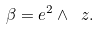<formula> <loc_0><loc_0><loc_500><loc_500>\beta = e ^ { 2 } \wedge \ z .</formula> 